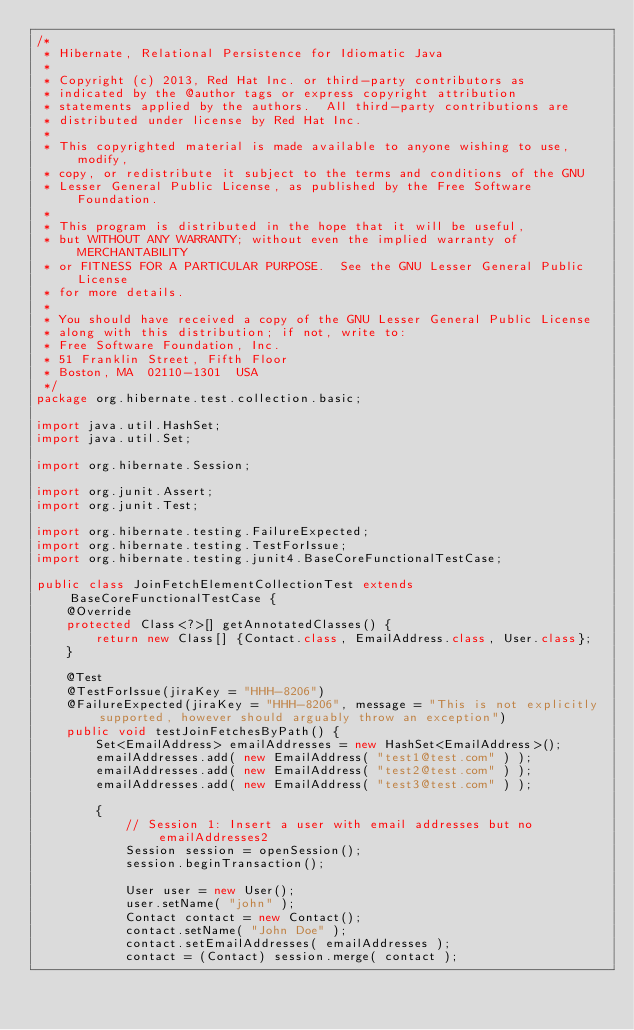Convert code to text. <code><loc_0><loc_0><loc_500><loc_500><_Java_>/*
 * Hibernate, Relational Persistence for Idiomatic Java
 *
 * Copyright (c) 2013, Red Hat Inc. or third-party contributors as
 * indicated by the @author tags or express copyright attribution
 * statements applied by the authors.  All third-party contributions are
 * distributed under license by Red Hat Inc.
 *
 * This copyrighted material is made available to anyone wishing to use, modify,
 * copy, or redistribute it subject to the terms and conditions of the GNU
 * Lesser General Public License, as published by the Free Software Foundation.
 *
 * This program is distributed in the hope that it will be useful,
 * but WITHOUT ANY WARRANTY; without even the implied warranty of MERCHANTABILITY
 * or FITNESS FOR A PARTICULAR PURPOSE.  See the GNU Lesser General Public License
 * for more details.
 *
 * You should have received a copy of the GNU Lesser General Public License
 * along with this distribution; if not, write to:
 * Free Software Foundation, Inc.
 * 51 Franklin Street, Fifth Floor
 * Boston, MA  02110-1301  USA
 */
package org.hibernate.test.collection.basic;

import java.util.HashSet;
import java.util.Set;

import org.hibernate.Session;

import org.junit.Assert;
import org.junit.Test;

import org.hibernate.testing.FailureExpected;
import org.hibernate.testing.TestForIssue;
import org.hibernate.testing.junit4.BaseCoreFunctionalTestCase;

public class JoinFetchElementCollectionTest extends BaseCoreFunctionalTestCase {
	@Override
	protected Class<?>[] getAnnotatedClasses() {
		return new Class[] {Contact.class, EmailAddress.class, User.class};
	}

	@Test
	@TestForIssue(jiraKey = "HHH-8206")
	@FailureExpected(jiraKey = "HHH-8206", message = "This is not explicitly supported, however should arguably throw an exception")
	public void testJoinFetchesByPath() {
		Set<EmailAddress> emailAddresses = new HashSet<EmailAddress>();
		emailAddresses.add( new EmailAddress( "test1@test.com" ) );
		emailAddresses.add( new EmailAddress( "test2@test.com" ) );
		emailAddresses.add( new EmailAddress( "test3@test.com" ) );

		{
			// Session 1: Insert a user with email addresses but no emailAddresses2
			Session session = openSession();
			session.beginTransaction();

			User user = new User();
			user.setName( "john" );
			Contact contact = new Contact();
			contact.setName( "John Doe" );
			contact.setEmailAddresses( emailAddresses );
			contact = (Contact) session.merge( contact );</code> 